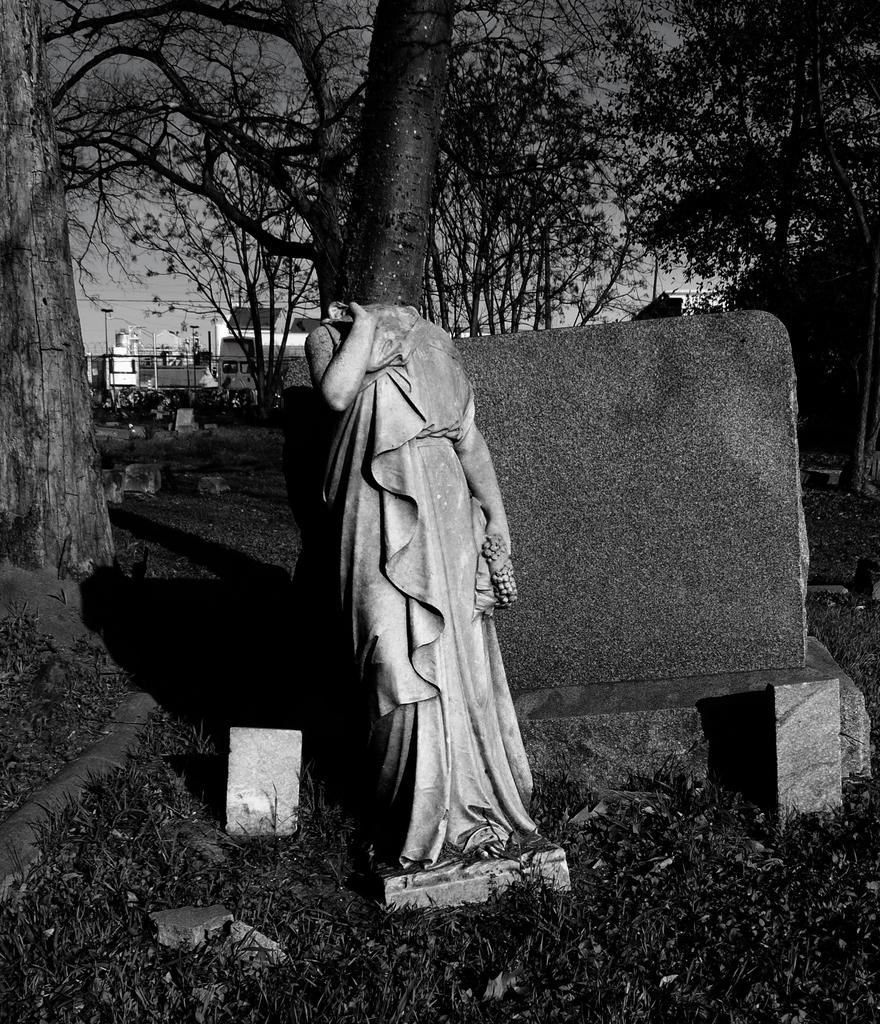What is the color scheme of the image? The image is black and white. What can be seen in the foreground of the image? There is a statue of a person in the image, and the head of the statue is broken. What can be seen in the background of the image? There are buildings, poles, trees, and the sky visible in the background of the image. What is the name of the person depicted in the frame in the image? There is no frame present in the image, and therefore no person can be depicted within a frame. 